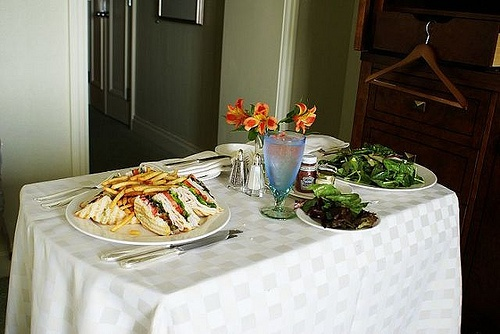Describe the objects in this image and their specific colors. I can see dining table in darkgray, beige, lightgray, and black tones, wine glass in darkgray and gray tones, sandwich in darkgray, khaki, tan, and black tones, sandwich in darkgray, beige, tan, and black tones, and sandwich in darkgray, beige, tan, and olive tones in this image. 